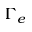<formula> <loc_0><loc_0><loc_500><loc_500>\Gamma _ { e }</formula> 